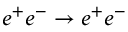<formula> <loc_0><loc_0><loc_500><loc_500>e ^ { + } e ^ { - } \to e ^ { + } e ^ { - }</formula> 